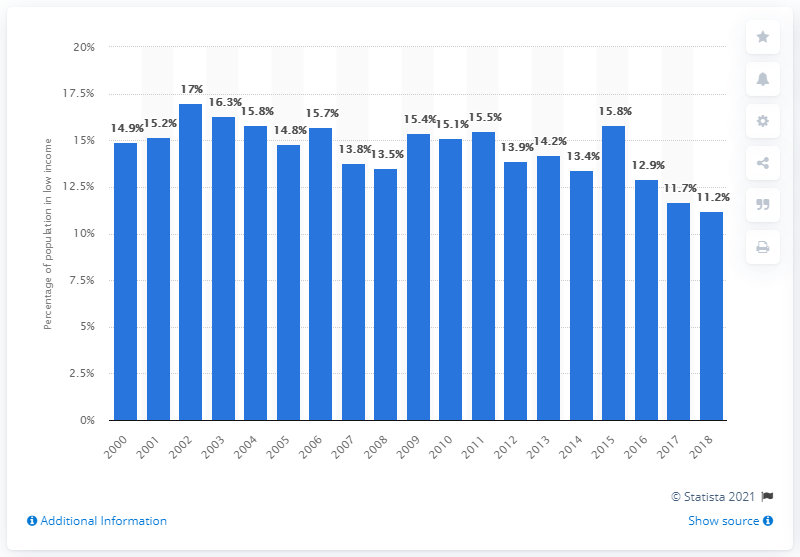Identify some key points in this picture. In 2018, approximately 11.2% of the population of British Columbia was considered to be in low income. 